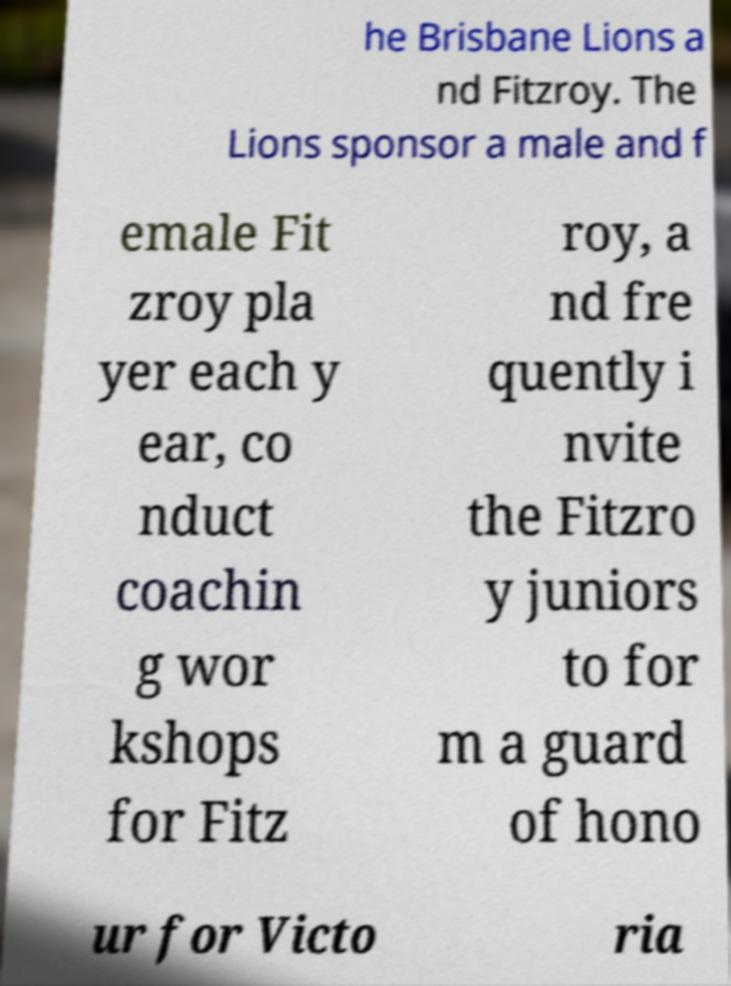Could you extract and type out the text from this image? he Brisbane Lions a nd Fitzroy. The Lions sponsor a male and f emale Fit zroy pla yer each y ear, co nduct coachin g wor kshops for Fitz roy, a nd fre quently i nvite the Fitzro y juniors to for m a guard of hono ur for Victo ria 